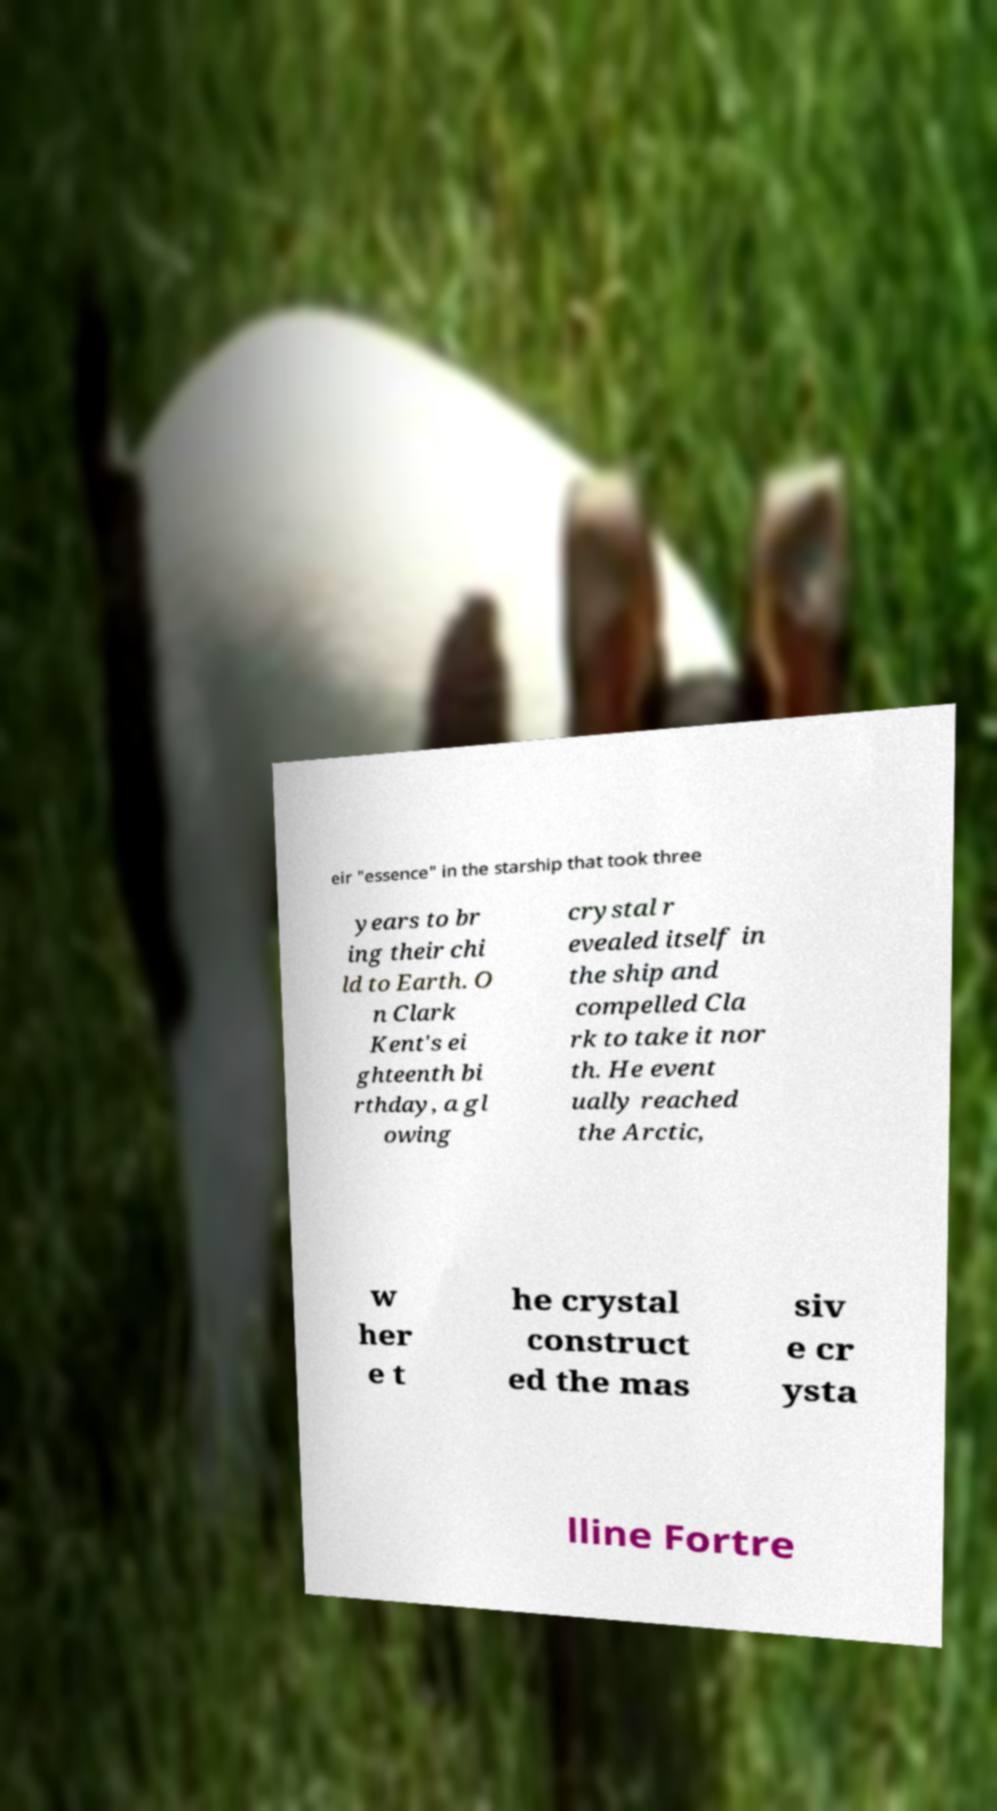For documentation purposes, I need the text within this image transcribed. Could you provide that? eir "essence" in the starship that took three years to br ing their chi ld to Earth. O n Clark Kent's ei ghteenth bi rthday, a gl owing crystal r evealed itself in the ship and compelled Cla rk to take it nor th. He event ually reached the Arctic, w her e t he crystal construct ed the mas siv e cr ysta lline Fortre 